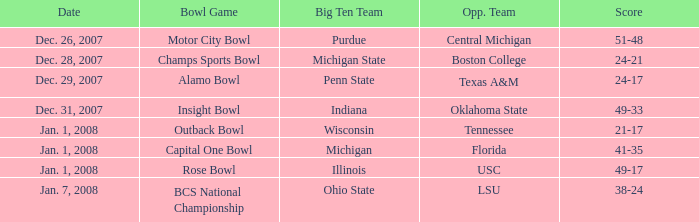What was the score of the BCS National Championship game? 38-24. 